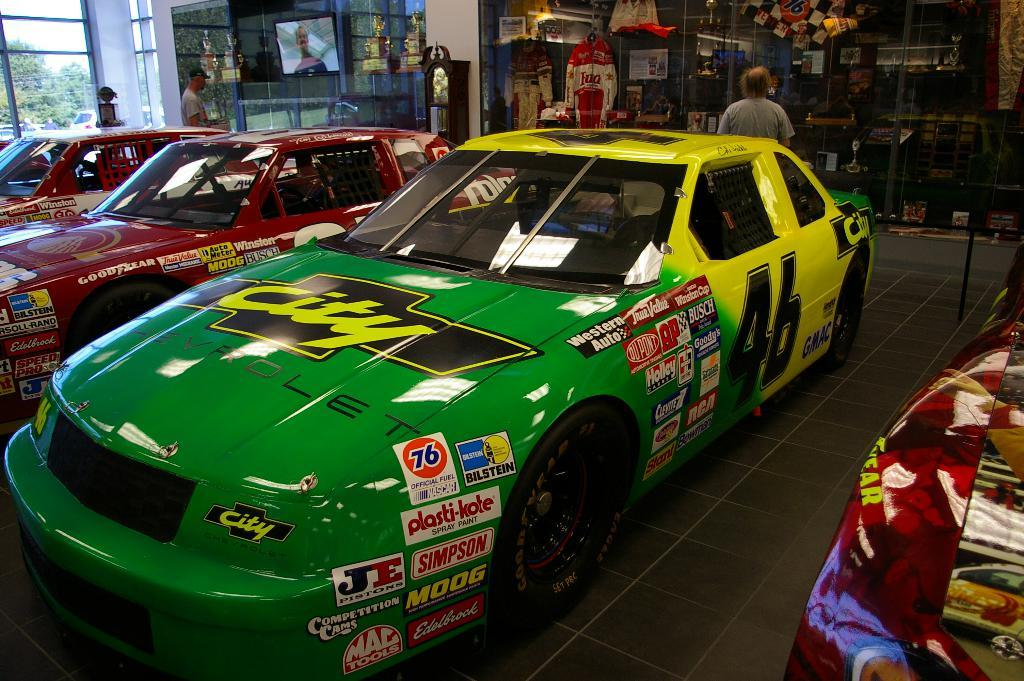<image>
Create a compact narrative representing the image presented. The green and yellow number 46 race car is displayed in a building. 